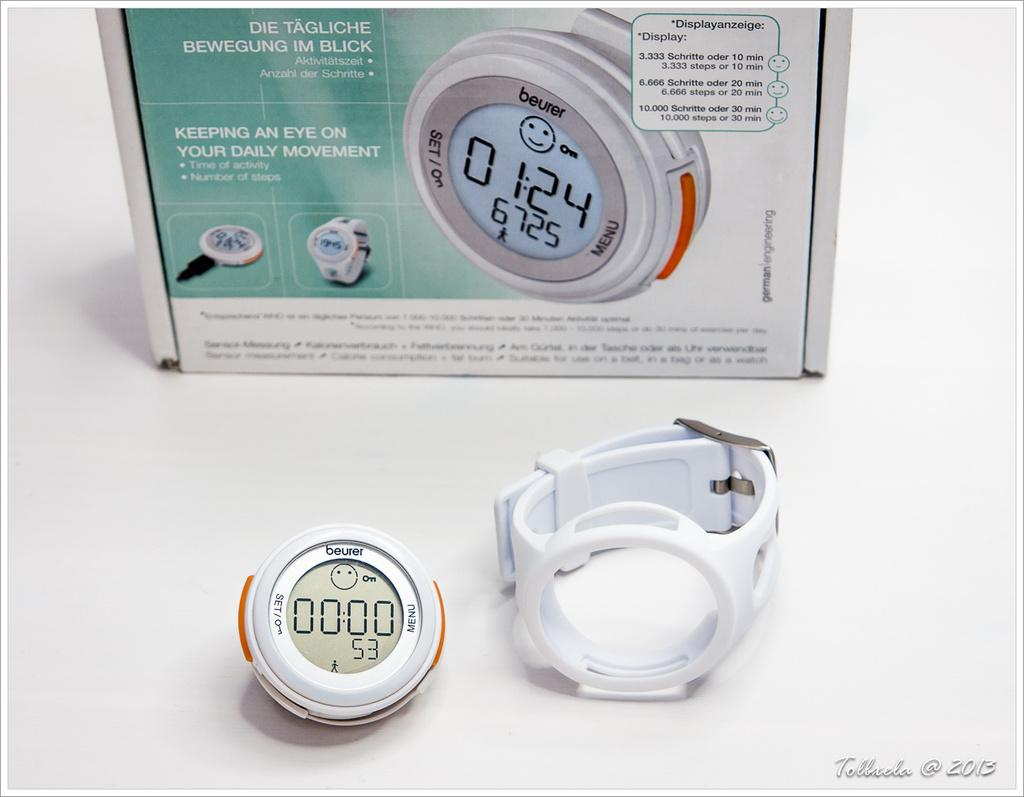<image>
Share a concise interpretation of the image provided. The Beurer watch face is detachable from its band. 